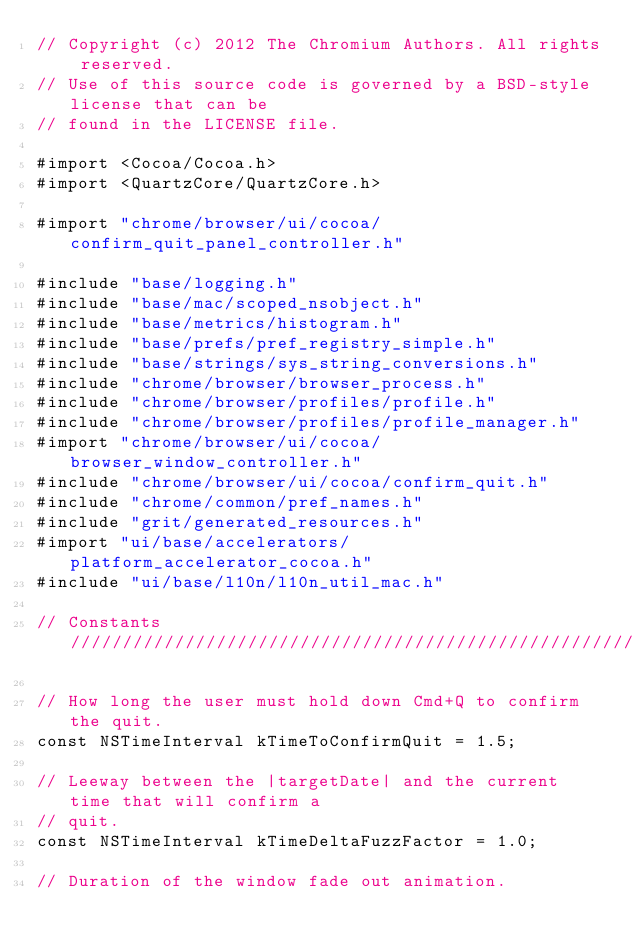<code> <loc_0><loc_0><loc_500><loc_500><_ObjectiveC_>// Copyright (c) 2012 The Chromium Authors. All rights reserved.
// Use of this source code is governed by a BSD-style license that can be
// found in the LICENSE file.

#import <Cocoa/Cocoa.h>
#import <QuartzCore/QuartzCore.h>

#import "chrome/browser/ui/cocoa/confirm_quit_panel_controller.h"

#include "base/logging.h"
#include "base/mac/scoped_nsobject.h"
#include "base/metrics/histogram.h"
#include "base/prefs/pref_registry_simple.h"
#include "base/strings/sys_string_conversions.h"
#include "chrome/browser/browser_process.h"
#include "chrome/browser/profiles/profile.h"
#include "chrome/browser/profiles/profile_manager.h"
#import "chrome/browser/ui/cocoa/browser_window_controller.h"
#include "chrome/browser/ui/cocoa/confirm_quit.h"
#include "chrome/common/pref_names.h"
#include "grit/generated_resources.h"
#import "ui/base/accelerators/platform_accelerator_cocoa.h"
#include "ui/base/l10n/l10n_util_mac.h"

// Constants ///////////////////////////////////////////////////////////////////

// How long the user must hold down Cmd+Q to confirm the quit.
const NSTimeInterval kTimeToConfirmQuit = 1.5;

// Leeway between the |targetDate| and the current time that will confirm a
// quit.
const NSTimeInterval kTimeDeltaFuzzFactor = 1.0;

// Duration of the window fade out animation.</code> 